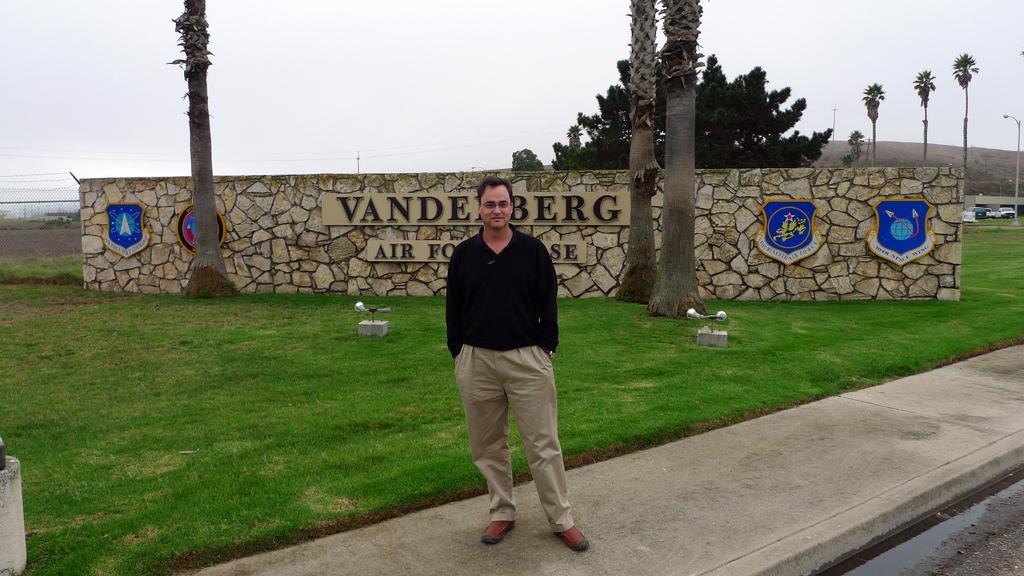Describe this image in one or two sentences. In this picture we can observe a man standing and smiling. He is wearing black color T shirt. Behind him there is some grass on the ground. We can observe some trees and a wall in the background. We can observe a sky here. 